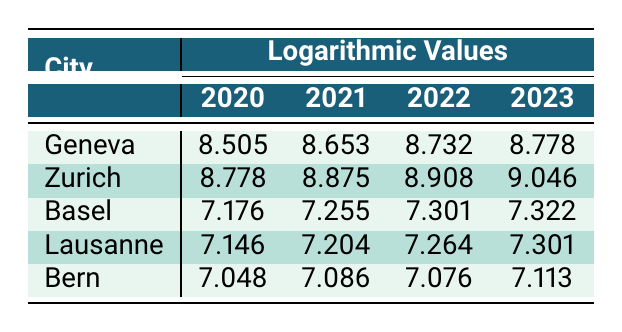What was the logarithmic value of commercial property transactions in Geneva in 2022? The table shows the logarithmic values for Geneva, which is 8.732 for the year 2022.
Answer: 8.732 In which year did Zurich's logarithmic value exceed Geneva's logarithmic value? By comparing the values, Zurich's logarithmic value was higher than Geneva's in all years listed: 8.778 in 2020, 8.875 in 2021, 8.908 in 2022, and 9.046 in 2023.
Answer: Every year What is the difference between the logarithmic values of commercial property transactions in Zurich and Basel for 2023? The logarithmic value for Zurich in 2023 is 9.046, and for Basel, it is 7.322. The difference is 9.046 - 7.322 = 1.724.
Answer: 1.724 Which city had the lowest logarithmic value in 2021? The table indicates that Bern had the lowest logarithmic value in 2021 at 7.086.
Answer: Bern What is the average of the logarithmic values for Lausanne from 2020 to 2023? The logarithmic values for Lausanne from 2020 to 2023 are: 7.146, 7.204, 7.264, 7.301. Add them together: 7.146 + 7.204 + 7.264 + 7.301 = 28.915, then divide by 4: 28.915 / 4 = 7.22875.
Answer: 7.229 